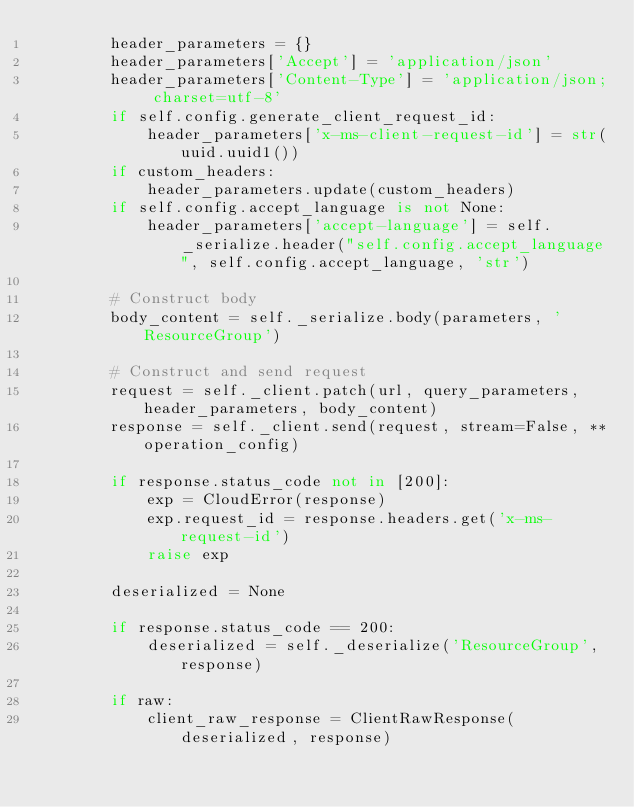Convert code to text. <code><loc_0><loc_0><loc_500><loc_500><_Python_>        header_parameters = {}
        header_parameters['Accept'] = 'application/json'
        header_parameters['Content-Type'] = 'application/json; charset=utf-8'
        if self.config.generate_client_request_id:
            header_parameters['x-ms-client-request-id'] = str(uuid.uuid1())
        if custom_headers:
            header_parameters.update(custom_headers)
        if self.config.accept_language is not None:
            header_parameters['accept-language'] = self._serialize.header("self.config.accept_language", self.config.accept_language, 'str')

        # Construct body
        body_content = self._serialize.body(parameters, 'ResourceGroup')

        # Construct and send request
        request = self._client.patch(url, query_parameters, header_parameters, body_content)
        response = self._client.send(request, stream=False, **operation_config)

        if response.status_code not in [200]:
            exp = CloudError(response)
            exp.request_id = response.headers.get('x-ms-request-id')
            raise exp

        deserialized = None

        if response.status_code == 200:
            deserialized = self._deserialize('ResourceGroup', response)

        if raw:
            client_raw_response = ClientRawResponse(deserialized, response)</code> 